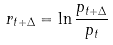<formula> <loc_0><loc_0><loc_500><loc_500>r _ { t + \Delta } = \ln \frac { p _ { t + \Delta } } { p _ { t } }</formula> 